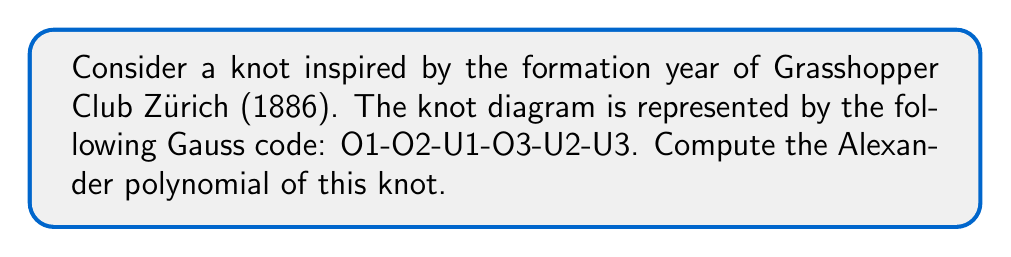Can you answer this question? Let's approach this step-by-step:

1) First, we need to create a knot diagram from the given Gauss code. The code O1-O2-U1-O3-U2-U3 represents a trefoil knot.

2) Now, we need to label the arcs of the knot. Let's label them a, b, and c.

3) Next, we create the Alexander matrix. For a knot with n crossings, this matrix will be (n-1) x n. In our case, it's a 2x3 matrix.

4) For each crossing, we write an equation:
   At O1: $t(b-a) = 0$
   At O2: $t(c-b) = 0$
   At O3: $t(a-c) = 0$

5) We can drop one of these equations (typically the last one) and form our matrix:

   $$
   \begin{pmatrix}
   -t & t & 0 \\
   0 & -t & t
   \end{pmatrix}
   $$

6) The Alexander polynomial is the determinant of any (n-1) x (n-1) minor of this matrix, divided by $(t-1)$.

7) Let's choose to delete the last column:

   $$\Delta(t) = \frac{1}{t-1} \det \begin{pmatrix} -t & t \\ 0 & -t \end{pmatrix}$$

8) Computing the determinant:

   $$\Delta(t) = \frac{1}{t-1} ((-t)(-t) - 0) = \frac{t^2}{t-1}$$

9) Simplify:

   $$\Delta(t) = \frac{t^2}{t-1} = t + 1$$

Thus, the Alexander polynomial of this knot is $t + 1$.
Answer: $t + 1$ 